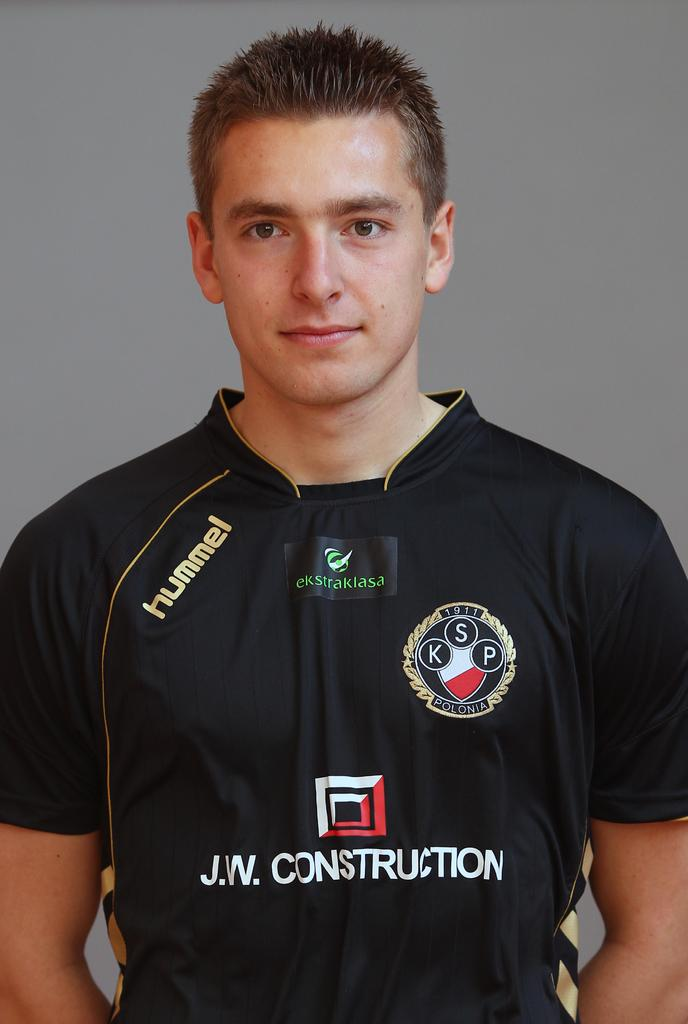Provide a one-sentence caption for the provided image. Man wearing a soccer jersey that says "J.W. Construction" on the front. 